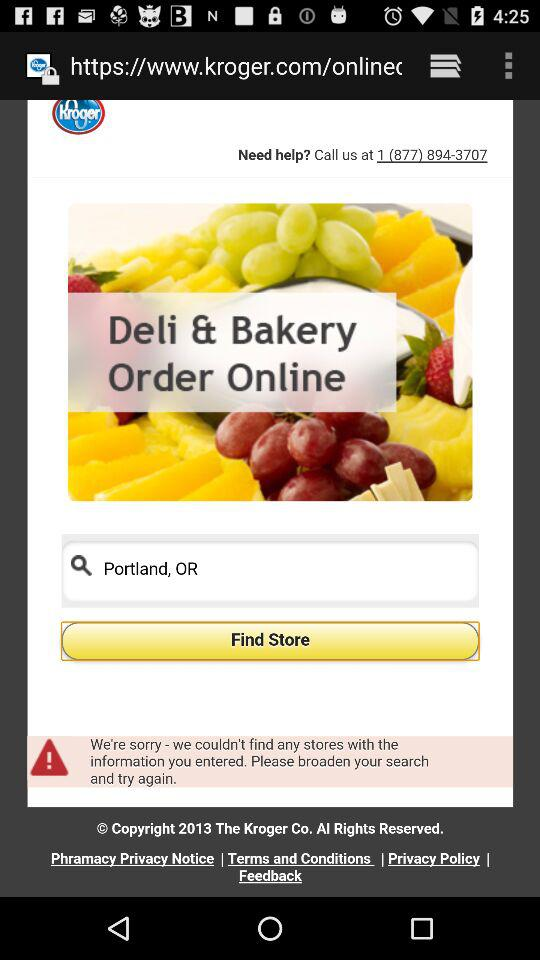What location is set on the application? The location is "Portland,OR". 